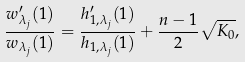Convert formula to latex. <formula><loc_0><loc_0><loc_500><loc_500>\frac { w _ { \lambda _ { j } } ^ { \prime } ( 1 ) } { w _ { \lambda _ { j } } ( 1 ) } = \frac { h _ { 1 , \lambda _ { j } } ^ { \prime } ( 1 ) } { h _ { 1 , \lambda _ { j } } ( 1 ) } + \frac { n - 1 } { 2 } \sqrt { K _ { 0 } } ,</formula> 